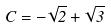Convert formula to latex. <formula><loc_0><loc_0><loc_500><loc_500>C = - \sqrt { 2 } + \sqrt { 3 }</formula> 